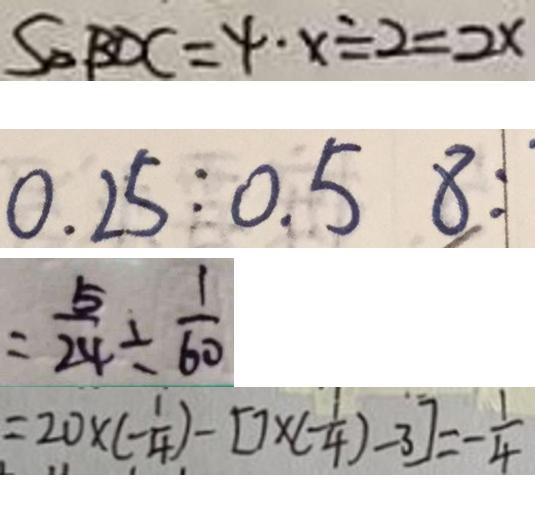<formula> <loc_0><loc_0><loc_500><loc_500>S _ { \Delta B D C } = 4 \cdot x \div 2 = 2 x 
 0 . 2 5 : 0 . 5 8 : 
 = \frac { 5 } { 2 4 } \div \frac { 1 } { 6 0 } 
 = 2 0 \times ( - \frac { 1 } { 4 } ) - [ 7 \times ( - \frac { 1 } { 4 } ) - 3 ] = - \frac { 1 } { 4 }</formula> 